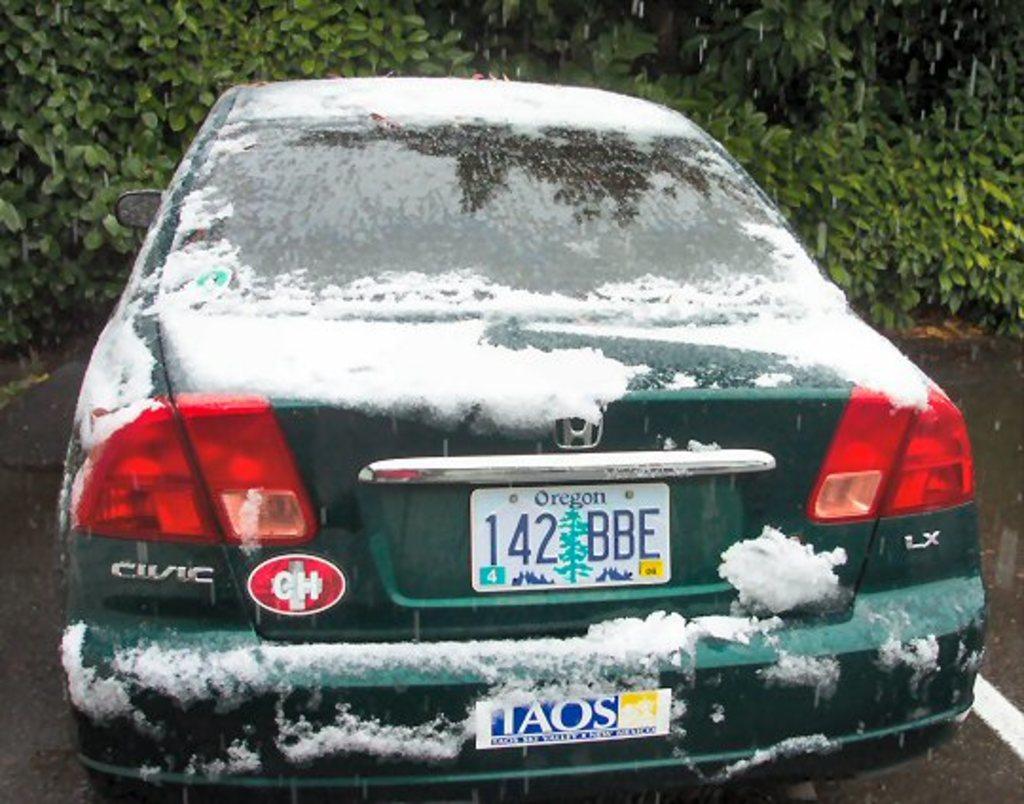What is written on the tag?
Your answer should be compact. 142 bbe. 